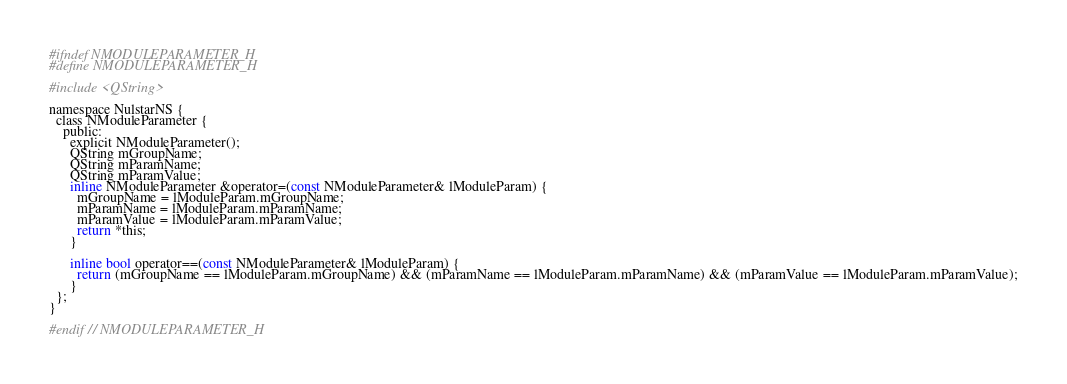<code> <loc_0><loc_0><loc_500><loc_500><_C_>#ifndef NMODULEPARAMETER_H
#define NMODULEPARAMETER_H

#include <QString>

namespace NulstarNS {
  class NModuleParameter {
    public:
      explicit NModuleParameter();
      QString mGroupName;
      QString mParamName;
      QString mParamValue;
      inline NModuleParameter &operator=(const NModuleParameter& lModuleParam) {
        mGroupName = lModuleParam.mGroupName;
        mParamName = lModuleParam.mParamName;
        mParamValue = lModuleParam.mParamValue;
        return *this;
      }

      inline bool operator==(const NModuleParameter& lModuleParam) {
        return (mGroupName == lModuleParam.mGroupName) && (mParamName == lModuleParam.mParamName) && (mParamValue == lModuleParam.mParamValue);
      }
  };
}

#endif // NMODULEPARAMETER_H
</code> 